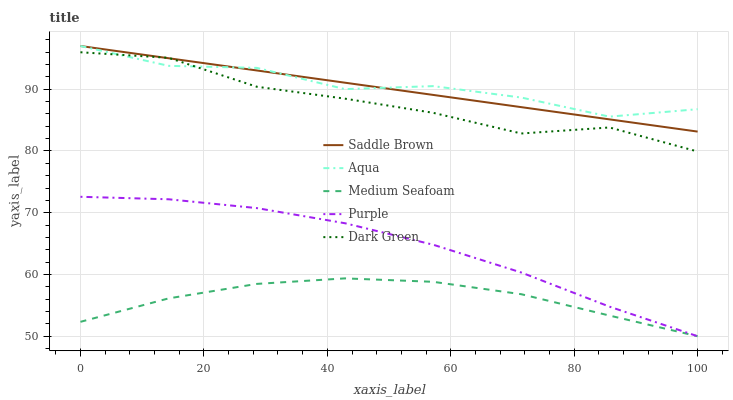Does Medium Seafoam have the minimum area under the curve?
Answer yes or no. Yes. Does Aqua have the maximum area under the curve?
Answer yes or no. Yes. Does Dark Green have the minimum area under the curve?
Answer yes or no. No. Does Dark Green have the maximum area under the curve?
Answer yes or no. No. Is Saddle Brown the smoothest?
Answer yes or no. Yes. Is Aqua the roughest?
Answer yes or no. Yes. Is Dark Green the smoothest?
Answer yes or no. No. Is Dark Green the roughest?
Answer yes or no. No. Does Dark Green have the lowest value?
Answer yes or no. No. Does Dark Green have the highest value?
Answer yes or no. No. Is Medium Seafoam less than Saddle Brown?
Answer yes or no. Yes. Is Saddle Brown greater than Purple?
Answer yes or no. Yes. Does Medium Seafoam intersect Saddle Brown?
Answer yes or no. No. 